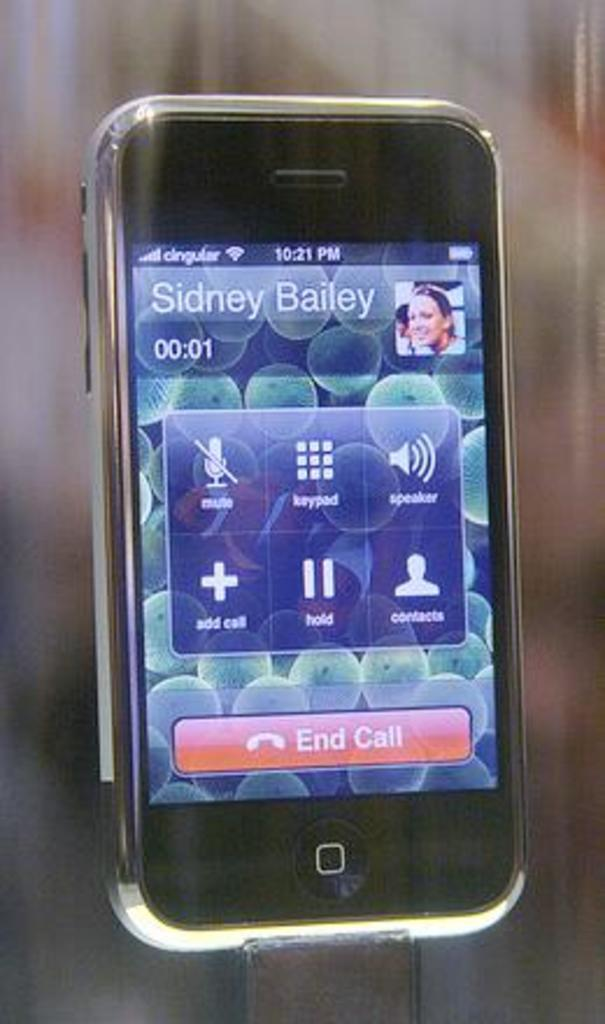<image>
Write a terse but informative summary of the picture. A cell phone with a picture and Sidney Bailey at the top. 